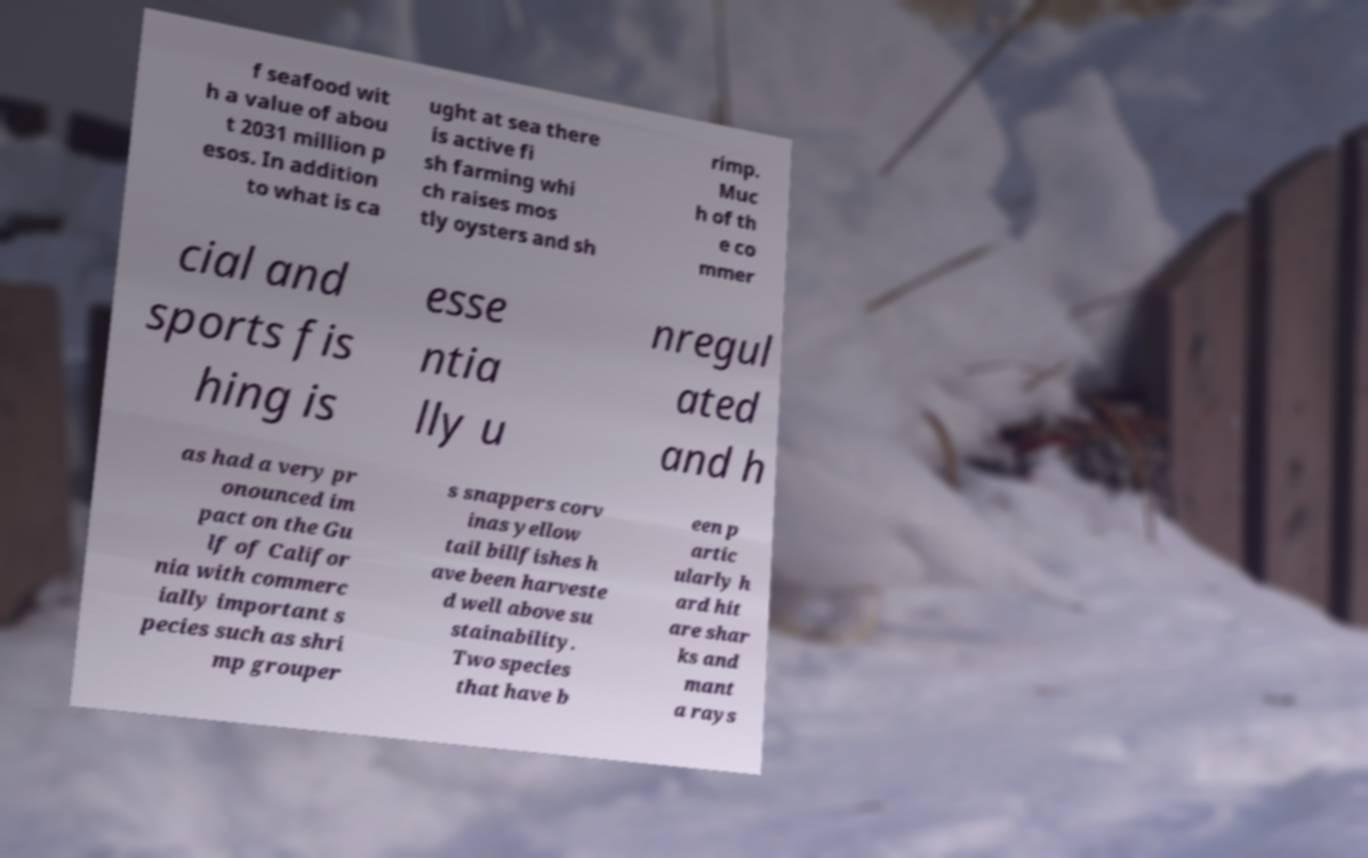For documentation purposes, I need the text within this image transcribed. Could you provide that? f seafood wit h a value of abou t 2031 million p esos. In addition to what is ca ught at sea there is active fi sh farming whi ch raises mos tly oysters and sh rimp. Muc h of th e co mmer cial and sports fis hing is esse ntia lly u nregul ated and h as had a very pr onounced im pact on the Gu lf of Califor nia with commerc ially important s pecies such as shri mp grouper s snappers corv inas yellow tail billfishes h ave been harveste d well above su stainability. Two species that have b een p artic ularly h ard hit are shar ks and mant a rays 